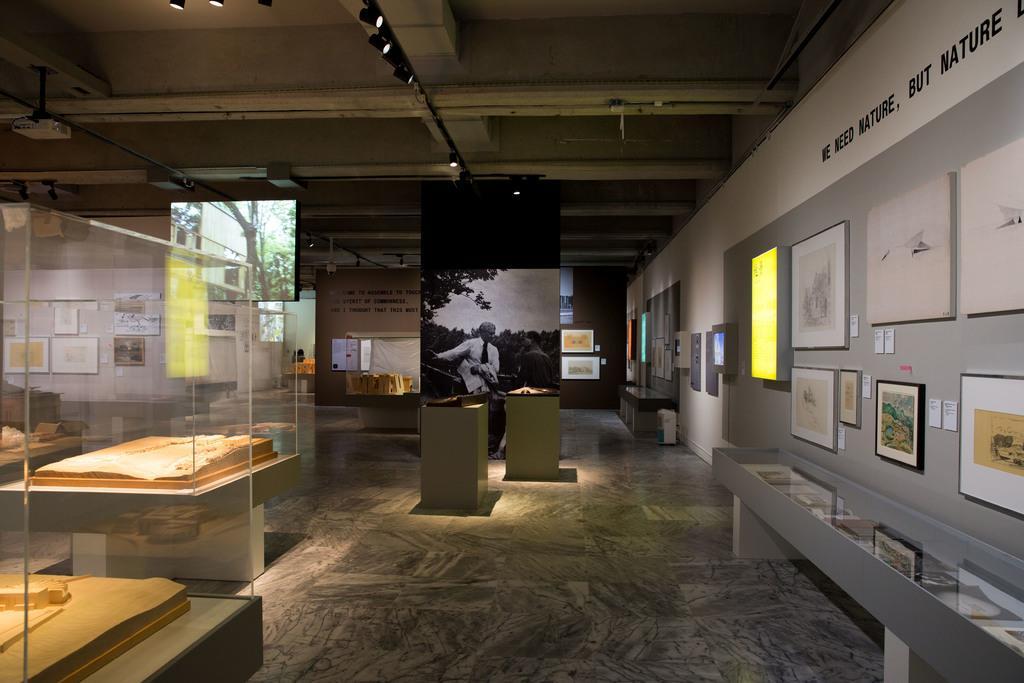Describe this image in one or two sentences. In this image we can see the glass boxes on the left side. Here we can see the photo frames on the wall on the right side. This is looking like a hoarding board. Here we can see the lighting arrangement on the roof. 